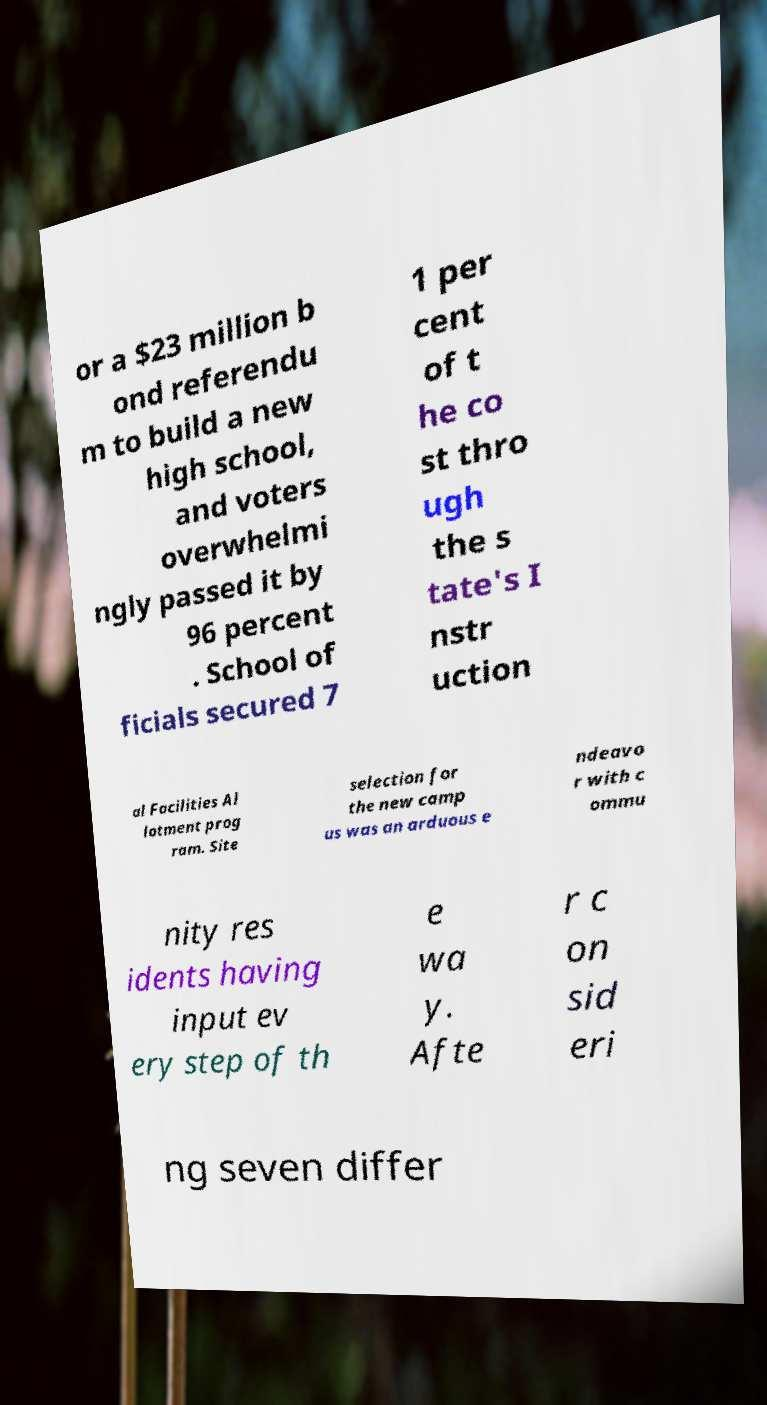What messages or text are displayed in this image? I need them in a readable, typed format. or a $23 million b ond referendu m to build a new high school, and voters overwhelmi ngly passed it by 96 percent . School of ficials secured 7 1 per cent of t he co st thro ugh the s tate's I nstr uction al Facilities Al lotment prog ram. Site selection for the new camp us was an arduous e ndeavo r with c ommu nity res idents having input ev ery step of th e wa y. Afte r c on sid eri ng seven differ 